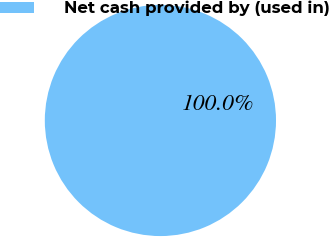Convert chart to OTSL. <chart><loc_0><loc_0><loc_500><loc_500><pie_chart><fcel>Net cash provided by (used in)<nl><fcel>100.0%<nl></chart> 